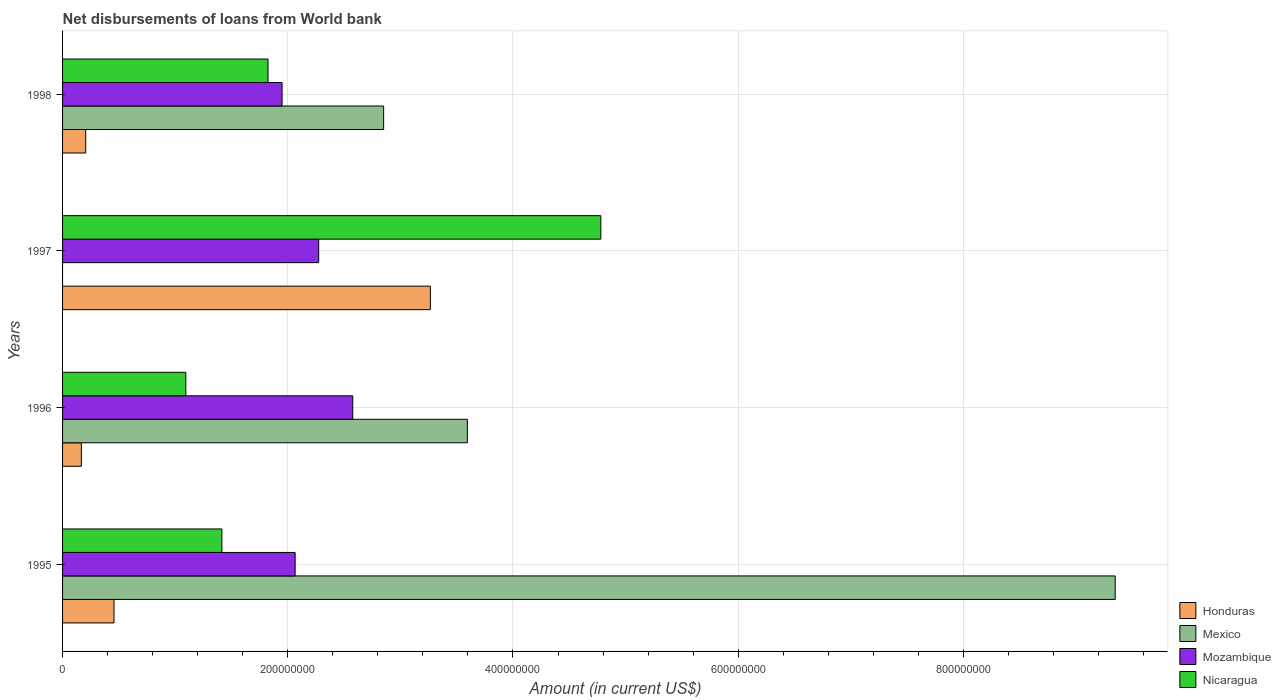How many groups of bars are there?
Ensure brevity in your answer.  4. How many bars are there on the 2nd tick from the top?
Ensure brevity in your answer.  3. What is the label of the 4th group of bars from the top?
Keep it short and to the point. 1995. In how many cases, is the number of bars for a given year not equal to the number of legend labels?
Offer a terse response. 1. What is the amount of loan disbursed from World Bank in Honduras in 1997?
Offer a very short reply. 3.27e+08. Across all years, what is the maximum amount of loan disbursed from World Bank in Honduras?
Offer a very short reply. 3.27e+08. Across all years, what is the minimum amount of loan disbursed from World Bank in Nicaragua?
Offer a terse response. 1.09e+08. What is the total amount of loan disbursed from World Bank in Mexico in the graph?
Your response must be concise. 1.58e+09. What is the difference between the amount of loan disbursed from World Bank in Honduras in 1997 and that in 1998?
Offer a terse response. 3.06e+08. What is the difference between the amount of loan disbursed from World Bank in Honduras in 1995 and the amount of loan disbursed from World Bank in Mozambique in 1997?
Ensure brevity in your answer.  -1.82e+08. What is the average amount of loan disbursed from World Bank in Nicaragua per year?
Your answer should be compact. 2.28e+08. In the year 1996, what is the difference between the amount of loan disbursed from World Bank in Nicaragua and amount of loan disbursed from World Bank in Mexico?
Offer a very short reply. -2.50e+08. What is the ratio of the amount of loan disbursed from World Bank in Mexico in 1996 to that in 1998?
Provide a succinct answer. 1.26. What is the difference between the highest and the second highest amount of loan disbursed from World Bank in Honduras?
Make the answer very short. 2.81e+08. What is the difference between the highest and the lowest amount of loan disbursed from World Bank in Honduras?
Ensure brevity in your answer.  3.10e+08. Is it the case that in every year, the sum of the amount of loan disbursed from World Bank in Nicaragua and amount of loan disbursed from World Bank in Mozambique is greater than the sum of amount of loan disbursed from World Bank in Mexico and amount of loan disbursed from World Bank in Honduras?
Offer a terse response. No. Where does the legend appear in the graph?
Your answer should be compact. Bottom right. How are the legend labels stacked?
Offer a very short reply. Vertical. What is the title of the graph?
Your response must be concise. Net disbursements of loans from World bank. Does "Bahrain" appear as one of the legend labels in the graph?
Your response must be concise. No. What is the label or title of the Y-axis?
Your answer should be compact. Years. What is the Amount (in current US$) in Honduras in 1995?
Offer a very short reply. 4.57e+07. What is the Amount (in current US$) of Mexico in 1995?
Your answer should be very brief. 9.35e+08. What is the Amount (in current US$) of Mozambique in 1995?
Ensure brevity in your answer.  2.07e+08. What is the Amount (in current US$) in Nicaragua in 1995?
Ensure brevity in your answer.  1.41e+08. What is the Amount (in current US$) in Honduras in 1996?
Ensure brevity in your answer.  1.67e+07. What is the Amount (in current US$) of Mexico in 1996?
Keep it short and to the point. 3.59e+08. What is the Amount (in current US$) in Mozambique in 1996?
Offer a terse response. 2.58e+08. What is the Amount (in current US$) of Nicaragua in 1996?
Your response must be concise. 1.09e+08. What is the Amount (in current US$) of Honduras in 1997?
Offer a very short reply. 3.27e+08. What is the Amount (in current US$) in Mozambique in 1997?
Make the answer very short. 2.27e+08. What is the Amount (in current US$) of Nicaragua in 1997?
Provide a succinct answer. 4.78e+08. What is the Amount (in current US$) in Honduras in 1998?
Offer a terse response. 2.05e+07. What is the Amount (in current US$) of Mexico in 1998?
Give a very brief answer. 2.85e+08. What is the Amount (in current US$) of Mozambique in 1998?
Offer a very short reply. 1.95e+08. What is the Amount (in current US$) in Nicaragua in 1998?
Give a very brief answer. 1.82e+08. Across all years, what is the maximum Amount (in current US$) in Honduras?
Keep it short and to the point. 3.27e+08. Across all years, what is the maximum Amount (in current US$) of Mexico?
Offer a very short reply. 9.35e+08. Across all years, what is the maximum Amount (in current US$) in Mozambique?
Keep it short and to the point. 2.58e+08. Across all years, what is the maximum Amount (in current US$) of Nicaragua?
Keep it short and to the point. 4.78e+08. Across all years, what is the minimum Amount (in current US$) in Honduras?
Offer a terse response. 1.67e+07. Across all years, what is the minimum Amount (in current US$) in Mozambique?
Offer a terse response. 1.95e+08. Across all years, what is the minimum Amount (in current US$) of Nicaragua?
Keep it short and to the point. 1.09e+08. What is the total Amount (in current US$) of Honduras in the graph?
Ensure brevity in your answer.  4.10e+08. What is the total Amount (in current US$) of Mexico in the graph?
Provide a short and direct response. 1.58e+09. What is the total Amount (in current US$) of Mozambique in the graph?
Ensure brevity in your answer.  8.87e+08. What is the total Amount (in current US$) in Nicaragua in the graph?
Offer a terse response. 9.11e+08. What is the difference between the Amount (in current US$) in Honduras in 1995 and that in 1996?
Your answer should be very brief. 2.90e+07. What is the difference between the Amount (in current US$) in Mexico in 1995 and that in 1996?
Your answer should be very brief. 5.75e+08. What is the difference between the Amount (in current US$) in Mozambique in 1995 and that in 1996?
Offer a terse response. -5.12e+07. What is the difference between the Amount (in current US$) of Nicaragua in 1995 and that in 1996?
Make the answer very short. 3.20e+07. What is the difference between the Amount (in current US$) in Honduras in 1995 and that in 1997?
Provide a short and direct response. -2.81e+08. What is the difference between the Amount (in current US$) of Mozambique in 1995 and that in 1997?
Your answer should be compact. -2.09e+07. What is the difference between the Amount (in current US$) of Nicaragua in 1995 and that in 1997?
Offer a very short reply. -3.37e+08. What is the difference between the Amount (in current US$) in Honduras in 1995 and that in 1998?
Your answer should be very brief. 2.51e+07. What is the difference between the Amount (in current US$) of Mexico in 1995 and that in 1998?
Provide a succinct answer. 6.50e+08. What is the difference between the Amount (in current US$) of Mozambique in 1995 and that in 1998?
Your answer should be compact. 1.16e+07. What is the difference between the Amount (in current US$) of Nicaragua in 1995 and that in 1998?
Your response must be concise. -4.10e+07. What is the difference between the Amount (in current US$) in Honduras in 1996 and that in 1997?
Ensure brevity in your answer.  -3.10e+08. What is the difference between the Amount (in current US$) in Mozambique in 1996 and that in 1997?
Your response must be concise. 3.03e+07. What is the difference between the Amount (in current US$) in Nicaragua in 1996 and that in 1997?
Keep it short and to the point. -3.69e+08. What is the difference between the Amount (in current US$) of Honduras in 1996 and that in 1998?
Your answer should be compact. -3.87e+06. What is the difference between the Amount (in current US$) of Mexico in 1996 and that in 1998?
Give a very brief answer. 7.44e+07. What is the difference between the Amount (in current US$) in Mozambique in 1996 and that in 1998?
Your response must be concise. 6.28e+07. What is the difference between the Amount (in current US$) of Nicaragua in 1996 and that in 1998?
Your answer should be compact. -7.30e+07. What is the difference between the Amount (in current US$) in Honduras in 1997 and that in 1998?
Give a very brief answer. 3.06e+08. What is the difference between the Amount (in current US$) of Mozambique in 1997 and that in 1998?
Provide a short and direct response. 3.25e+07. What is the difference between the Amount (in current US$) in Nicaragua in 1997 and that in 1998?
Keep it short and to the point. 2.96e+08. What is the difference between the Amount (in current US$) of Honduras in 1995 and the Amount (in current US$) of Mexico in 1996?
Provide a short and direct response. -3.14e+08. What is the difference between the Amount (in current US$) of Honduras in 1995 and the Amount (in current US$) of Mozambique in 1996?
Make the answer very short. -2.12e+08. What is the difference between the Amount (in current US$) of Honduras in 1995 and the Amount (in current US$) of Nicaragua in 1996?
Give a very brief answer. -6.38e+07. What is the difference between the Amount (in current US$) of Mexico in 1995 and the Amount (in current US$) of Mozambique in 1996?
Offer a terse response. 6.77e+08. What is the difference between the Amount (in current US$) in Mexico in 1995 and the Amount (in current US$) in Nicaragua in 1996?
Keep it short and to the point. 8.25e+08. What is the difference between the Amount (in current US$) of Mozambique in 1995 and the Amount (in current US$) of Nicaragua in 1996?
Keep it short and to the point. 9.71e+07. What is the difference between the Amount (in current US$) of Honduras in 1995 and the Amount (in current US$) of Mozambique in 1997?
Offer a very short reply. -1.82e+08. What is the difference between the Amount (in current US$) in Honduras in 1995 and the Amount (in current US$) in Nicaragua in 1997?
Provide a succinct answer. -4.32e+08. What is the difference between the Amount (in current US$) in Mexico in 1995 and the Amount (in current US$) in Mozambique in 1997?
Offer a very short reply. 7.07e+08. What is the difference between the Amount (in current US$) in Mexico in 1995 and the Amount (in current US$) in Nicaragua in 1997?
Ensure brevity in your answer.  4.57e+08. What is the difference between the Amount (in current US$) of Mozambique in 1995 and the Amount (in current US$) of Nicaragua in 1997?
Your response must be concise. -2.71e+08. What is the difference between the Amount (in current US$) in Honduras in 1995 and the Amount (in current US$) in Mexico in 1998?
Give a very brief answer. -2.39e+08. What is the difference between the Amount (in current US$) of Honduras in 1995 and the Amount (in current US$) of Mozambique in 1998?
Give a very brief answer. -1.49e+08. What is the difference between the Amount (in current US$) of Honduras in 1995 and the Amount (in current US$) of Nicaragua in 1998?
Offer a terse response. -1.37e+08. What is the difference between the Amount (in current US$) of Mexico in 1995 and the Amount (in current US$) of Mozambique in 1998?
Your response must be concise. 7.40e+08. What is the difference between the Amount (in current US$) in Mexico in 1995 and the Amount (in current US$) in Nicaragua in 1998?
Ensure brevity in your answer.  7.52e+08. What is the difference between the Amount (in current US$) of Mozambique in 1995 and the Amount (in current US$) of Nicaragua in 1998?
Keep it short and to the point. 2.41e+07. What is the difference between the Amount (in current US$) of Honduras in 1996 and the Amount (in current US$) of Mozambique in 1997?
Offer a terse response. -2.11e+08. What is the difference between the Amount (in current US$) of Honduras in 1996 and the Amount (in current US$) of Nicaragua in 1997?
Your answer should be very brief. -4.61e+08. What is the difference between the Amount (in current US$) in Mexico in 1996 and the Amount (in current US$) in Mozambique in 1997?
Make the answer very short. 1.32e+08. What is the difference between the Amount (in current US$) of Mexico in 1996 and the Amount (in current US$) of Nicaragua in 1997?
Keep it short and to the point. -1.19e+08. What is the difference between the Amount (in current US$) in Mozambique in 1996 and the Amount (in current US$) in Nicaragua in 1997?
Ensure brevity in your answer.  -2.20e+08. What is the difference between the Amount (in current US$) of Honduras in 1996 and the Amount (in current US$) of Mexico in 1998?
Your answer should be compact. -2.68e+08. What is the difference between the Amount (in current US$) of Honduras in 1996 and the Amount (in current US$) of Mozambique in 1998?
Your answer should be very brief. -1.78e+08. What is the difference between the Amount (in current US$) of Honduras in 1996 and the Amount (in current US$) of Nicaragua in 1998?
Ensure brevity in your answer.  -1.66e+08. What is the difference between the Amount (in current US$) of Mexico in 1996 and the Amount (in current US$) of Mozambique in 1998?
Ensure brevity in your answer.  1.65e+08. What is the difference between the Amount (in current US$) in Mexico in 1996 and the Amount (in current US$) in Nicaragua in 1998?
Offer a very short reply. 1.77e+08. What is the difference between the Amount (in current US$) in Mozambique in 1996 and the Amount (in current US$) in Nicaragua in 1998?
Offer a very short reply. 7.53e+07. What is the difference between the Amount (in current US$) in Honduras in 1997 and the Amount (in current US$) in Mexico in 1998?
Make the answer very short. 4.15e+07. What is the difference between the Amount (in current US$) in Honduras in 1997 and the Amount (in current US$) in Mozambique in 1998?
Your response must be concise. 1.32e+08. What is the difference between the Amount (in current US$) in Honduras in 1997 and the Amount (in current US$) in Nicaragua in 1998?
Keep it short and to the point. 1.44e+08. What is the difference between the Amount (in current US$) of Mozambique in 1997 and the Amount (in current US$) of Nicaragua in 1998?
Make the answer very short. 4.50e+07. What is the average Amount (in current US$) in Honduras per year?
Keep it short and to the point. 1.02e+08. What is the average Amount (in current US$) of Mexico per year?
Provide a succinct answer. 3.95e+08. What is the average Amount (in current US$) of Mozambique per year?
Make the answer very short. 2.22e+08. What is the average Amount (in current US$) in Nicaragua per year?
Provide a short and direct response. 2.28e+08. In the year 1995, what is the difference between the Amount (in current US$) in Honduras and Amount (in current US$) in Mexico?
Offer a terse response. -8.89e+08. In the year 1995, what is the difference between the Amount (in current US$) of Honduras and Amount (in current US$) of Mozambique?
Your response must be concise. -1.61e+08. In the year 1995, what is the difference between the Amount (in current US$) in Honduras and Amount (in current US$) in Nicaragua?
Your response must be concise. -9.58e+07. In the year 1995, what is the difference between the Amount (in current US$) in Mexico and Amount (in current US$) in Mozambique?
Offer a very short reply. 7.28e+08. In the year 1995, what is the difference between the Amount (in current US$) of Mexico and Amount (in current US$) of Nicaragua?
Offer a terse response. 7.93e+08. In the year 1995, what is the difference between the Amount (in current US$) of Mozambique and Amount (in current US$) of Nicaragua?
Offer a very short reply. 6.51e+07. In the year 1996, what is the difference between the Amount (in current US$) in Honduras and Amount (in current US$) in Mexico?
Keep it short and to the point. -3.43e+08. In the year 1996, what is the difference between the Amount (in current US$) of Honduras and Amount (in current US$) of Mozambique?
Your answer should be compact. -2.41e+08. In the year 1996, what is the difference between the Amount (in current US$) in Honduras and Amount (in current US$) in Nicaragua?
Offer a very short reply. -9.28e+07. In the year 1996, what is the difference between the Amount (in current US$) in Mexico and Amount (in current US$) in Mozambique?
Ensure brevity in your answer.  1.02e+08. In the year 1996, what is the difference between the Amount (in current US$) in Mexico and Amount (in current US$) in Nicaragua?
Make the answer very short. 2.50e+08. In the year 1996, what is the difference between the Amount (in current US$) of Mozambique and Amount (in current US$) of Nicaragua?
Ensure brevity in your answer.  1.48e+08. In the year 1997, what is the difference between the Amount (in current US$) of Honduras and Amount (in current US$) of Mozambique?
Your answer should be compact. 9.91e+07. In the year 1997, what is the difference between the Amount (in current US$) in Honduras and Amount (in current US$) in Nicaragua?
Your answer should be very brief. -1.51e+08. In the year 1997, what is the difference between the Amount (in current US$) in Mozambique and Amount (in current US$) in Nicaragua?
Your answer should be compact. -2.51e+08. In the year 1998, what is the difference between the Amount (in current US$) of Honduras and Amount (in current US$) of Mexico?
Your response must be concise. -2.65e+08. In the year 1998, what is the difference between the Amount (in current US$) in Honduras and Amount (in current US$) in Mozambique?
Your response must be concise. -1.74e+08. In the year 1998, what is the difference between the Amount (in current US$) of Honduras and Amount (in current US$) of Nicaragua?
Make the answer very short. -1.62e+08. In the year 1998, what is the difference between the Amount (in current US$) in Mexico and Amount (in current US$) in Mozambique?
Keep it short and to the point. 9.02e+07. In the year 1998, what is the difference between the Amount (in current US$) in Mexico and Amount (in current US$) in Nicaragua?
Provide a short and direct response. 1.03e+08. In the year 1998, what is the difference between the Amount (in current US$) in Mozambique and Amount (in current US$) in Nicaragua?
Make the answer very short. 1.25e+07. What is the ratio of the Amount (in current US$) of Honduras in 1995 to that in 1996?
Offer a terse response. 2.74. What is the ratio of the Amount (in current US$) of Mexico in 1995 to that in 1996?
Make the answer very short. 2.6. What is the ratio of the Amount (in current US$) in Mozambique in 1995 to that in 1996?
Make the answer very short. 0.8. What is the ratio of the Amount (in current US$) of Nicaragua in 1995 to that in 1996?
Offer a terse response. 1.29. What is the ratio of the Amount (in current US$) of Honduras in 1995 to that in 1997?
Offer a very short reply. 0.14. What is the ratio of the Amount (in current US$) of Mozambique in 1995 to that in 1997?
Your answer should be compact. 0.91. What is the ratio of the Amount (in current US$) of Nicaragua in 1995 to that in 1997?
Your answer should be compact. 0.3. What is the ratio of the Amount (in current US$) of Honduras in 1995 to that in 1998?
Your answer should be very brief. 2.22. What is the ratio of the Amount (in current US$) in Mexico in 1995 to that in 1998?
Your answer should be compact. 3.28. What is the ratio of the Amount (in current US$) of Mozambique in 1995 to that in 1998?
Your answer should be compact. 1.06. What is the ratio of the Amount (in current US$) in Nicaragua in 1995 to that in 1998?
Your answer should be compact. 0.78. What is the ratio of the Amount (in current US$) in Honduras in 1996 to that in 1997?
Give a very brief answer. 0.05. What is the ratio of the Amount (in current US$) of Mozambique in 1996 to that in 1997?
Ensure brevity in your answer.  1.13. What is the ratio of the Amount (in current US$) in Nicaragua in 1996 to that in 1997?
Your answer should be compact. 0.23. What is the ratio of the Amount (in current US$) in Honduras in 1996 to that in 1998?
Your answer should be very brief. 0.81. What is the ratio of the Amount (in current US$) in Mexico in 1996 to that in 1998?
Your answer should be very brief. 1.26. What is the ratio of the Amount (in current US$) in Mozambique in 1996 to that in 1998?
Offer a very short reply. 1.32. What is the ratio of the Amount (in current US$) in Nicaragua in 1996 to that in 1998?
Provide a short and direct response. 0.6. What is the ratio of the Amount (in current US$) of Honduras in 1997 to that in 1998?
Give a very brief answer. 15.9. What is the ratio of the Amount (in current US$) of Mozambique in 1997 to that in 1998?
Offer a very short reply. 1.17. What is the ratio of the Amount (in current US$) in Nicaragua in 1997 to that in 1998?
Offer a very short reply. 2.62. What is the difference between the highest and the second highest Amount (in current US$) in Honduras?
Ensure brevity in your answer.  2.81e+08. What is the difference between the highest and the second highest Amount (in current US$) in Mexico?
Provide a short and direct response. 5.75e+08. What is the difference between the highest and the second highest Amount (in current US$) in Mozambique?
Offer a very short reply. 3.03e+07. What is the difference between the highest and the second highest Amount (in current US$) of Nicaragua?
Offer a terse response. 2.96e+08. What is the difference between the highest and the lowest Amount (in current US$) of Honduras?
Your response must be concise. 3.10e+08. What is the difference between the highest and the lowest Amount (in current US$) of Mexico?
Provide a succinct answer. 9.35e+08. What is the difference between the highest and the lowest Amount (in current US$) in Mozambique?
Provide a short and direct response. 6.28e+07. What is the difference between the highest and the lowest Amount (in current US$) in Nicaragua?
Ensure brevity in your answer.  3.69e+08. 